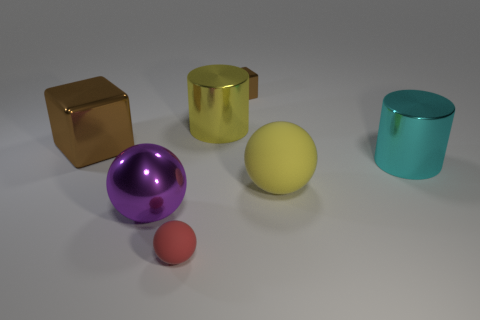Subtract all large spheres. How many spheres are left? 1 Add 2 large rubber spheres. How many objects exist? 9 Subtract 1 blocks. How many blocks are left? 1 Subtract all purple balls. How many balls are left? 2 Subtract all brown balls. Subtract all blue blocks. How many balls are left? 3 Subtract 1 brown cubes. How many objects are left? 6 Subtract all cylinders. How many objects are left? 5 Subtract all tiny blocks. Subtract all blocks. How many objects are left? 4 Add 6 cyan things. How many cyan things are left? 7 Add 1 big purple things. How many big purple things exist? 2 